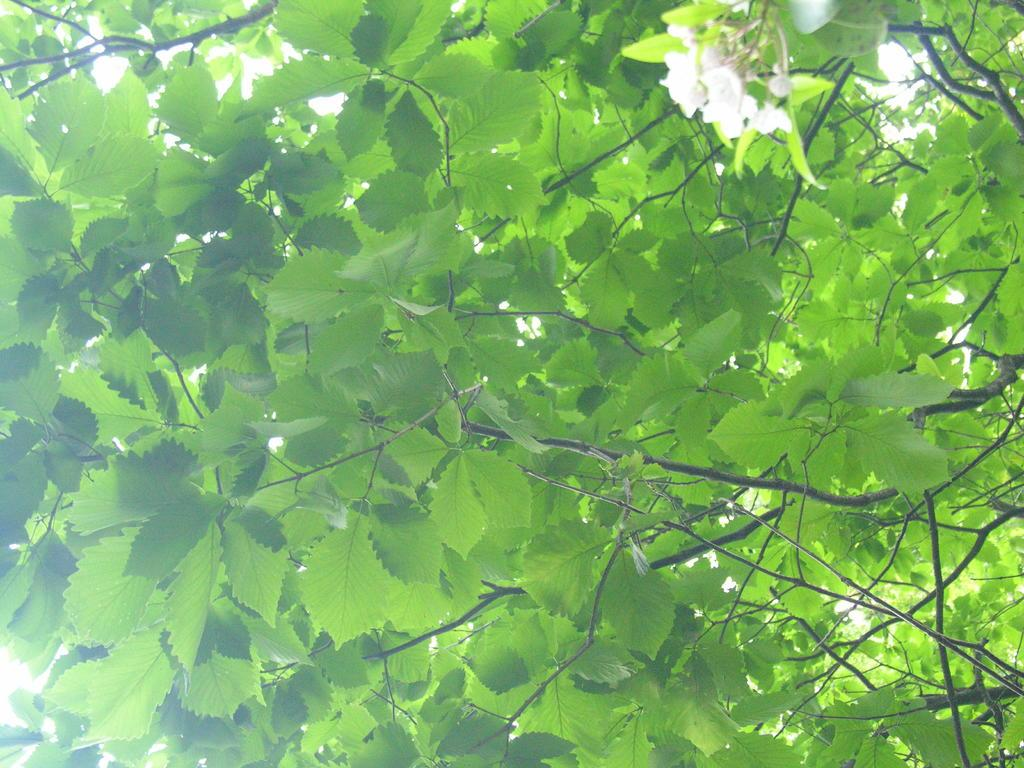What type of vegetation can be seen on the trees in the image? There are flowers on the trees in the image. What type of nerve can be seen in the image? There is no nerve present in the image; it features flowers on trees. 